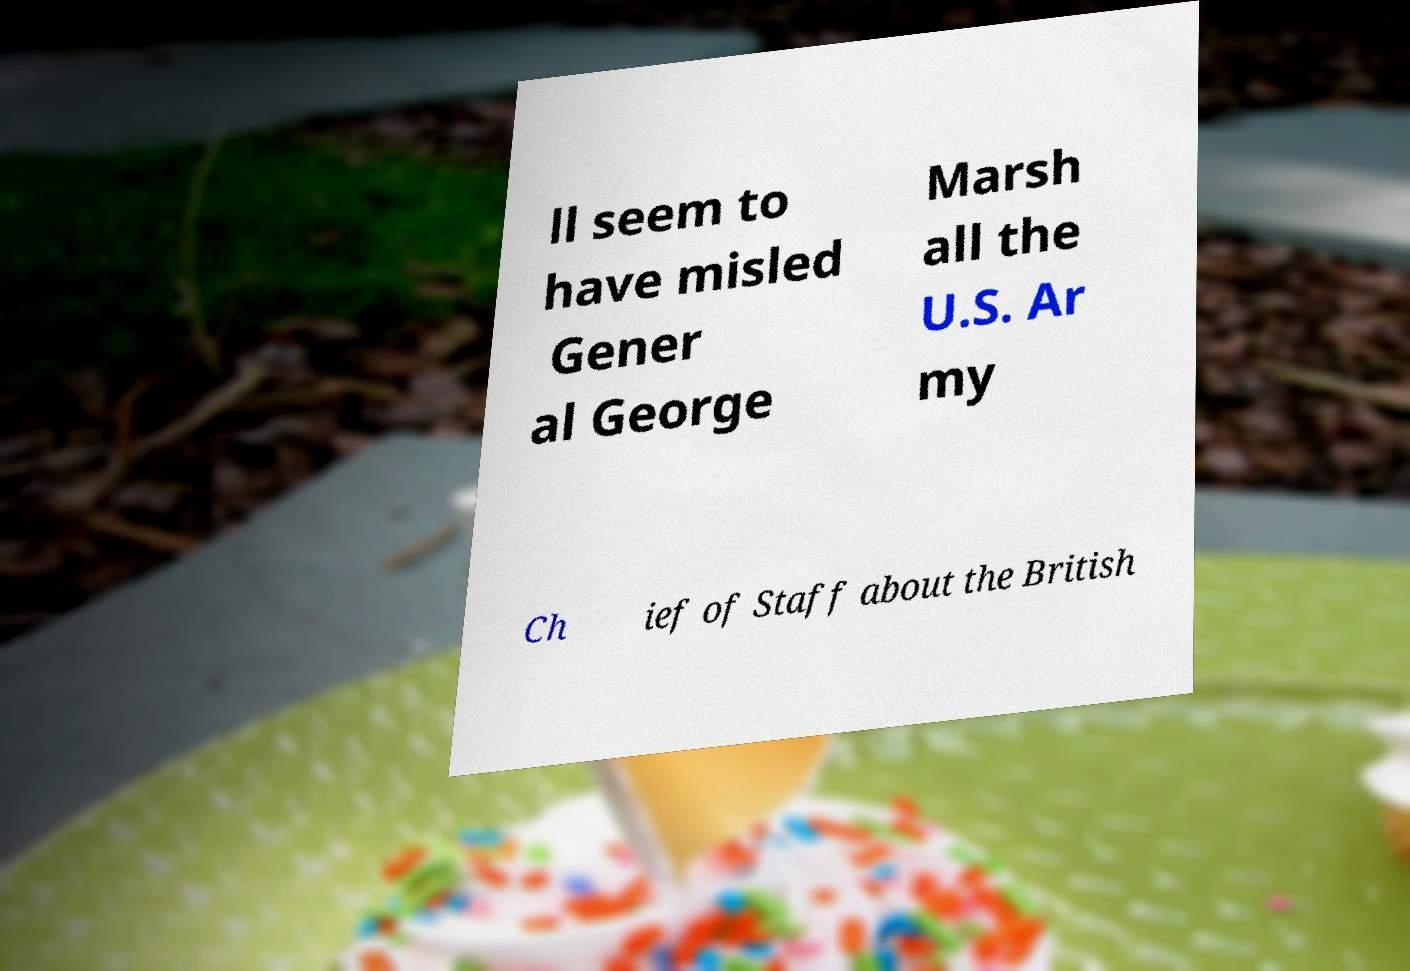Please identify and transcribe the text found in this image. ll seem to have misled Gener al George Marsh all the U.S. Ar my Ch ief of Staff about the British 